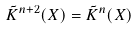<formula> <loc_0><loc_0><loc_500><loc_500>\tilde { K } ^ { n + 2 } ( X ) = \tilde { K } ^ { n } ( X )</formula> 